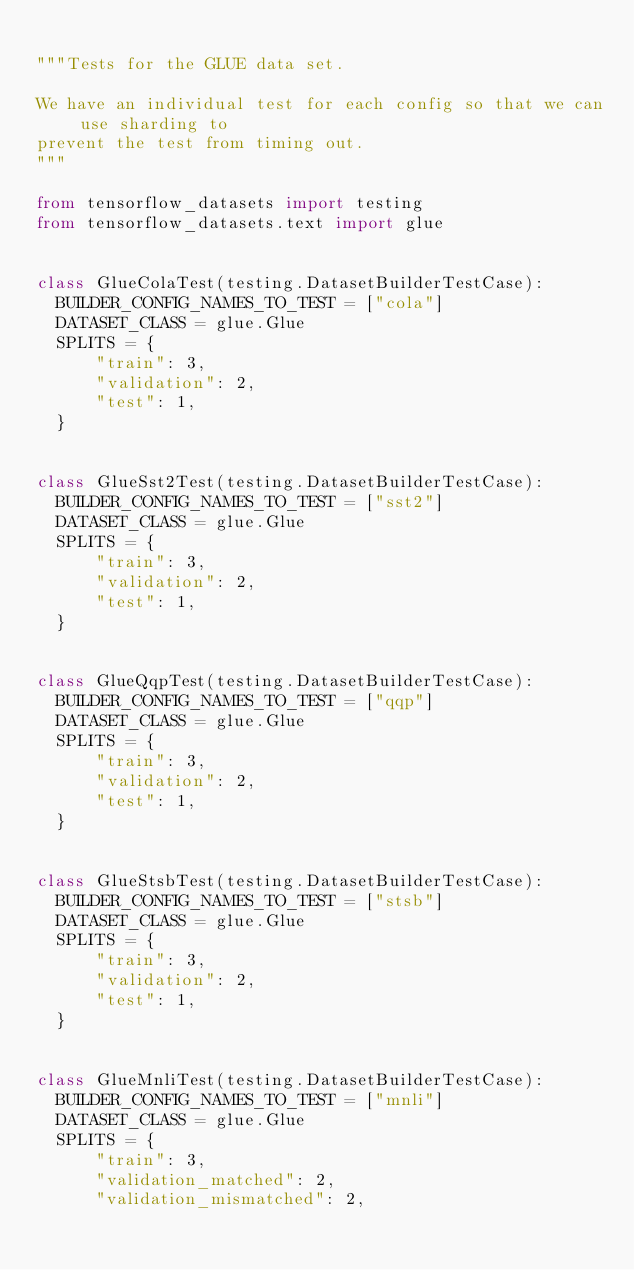<code> <loc_0><loc_0><loc_500><loc_500><_Python_>
"""Tests for the GLUE data set.

We have an individual test for each config so that we can use sharding to
prevent the test from timing out.
"""

from tensorflow_datasets import testing
from tensorflow_datasets.text import glue


class GlueColaTest(testing.DatasetBuilderTestCase):
  BUILDER_CONFIG_NAMES_TO_TEST = ["cola"]
  DATASET_CLASS = glue.Glue
  SPLITS = {
      "train": 3,
      "validation": 2,
      "test": 1,
  }


class GlueSst2Test(testing.DatasetBuilderTestCase):
  BUILDER_CONFIG_NAMES_TO_TEST = ["sst2"]
  DATASET_CLASS = glue.Glue
  SPLITS = {
      "train": 3,
      "validation": 2,
      "test": 1,
  }


class GlueQqpTest(testing.DatasetBuilderTestCase):
  BUILDER_CONFIG_NAMES_TO_TEST = ["qqp"]
  DATASET_CLASS = glue.Glue
  SPLITS = {
      "train": 3,
      "validation": 2,
      "test": 1,
  }


class GlueStsbTest(testing.DatasetBuilderTestCase):
  BUILDER_CONFIG_NAMES_TO_TEST = ["stsb"]
  DATASET_CLASS = glue.Glue
  SPLITS = {
      "train": 3,
      "validation": 2,
      "test": 1,
  }


class GlueMnliTest(testing.DatasetBuilderTestCase):
  BUILDER_CONFIG_NAMES_TO_TEST = ["mnli"]
  DATASET_CLASS = glue.Glue
  SPLITS = {
      "train": 3,
      "validation_matched": 2,
      "validation_mismatched": 2,</code> 